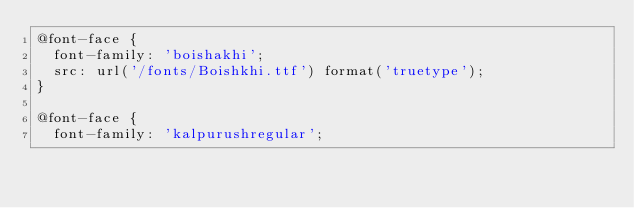Convert code to text. <code><loc_0><loc_0><loc_500><loc_500><_CSS_>@font-face {
	font-family: 'boishakhi';
	src: url('/fonts/Boishkhi.ttf') format('truetype');
}

@font-face {
	font-family: 'kalpurushregular';</code> 